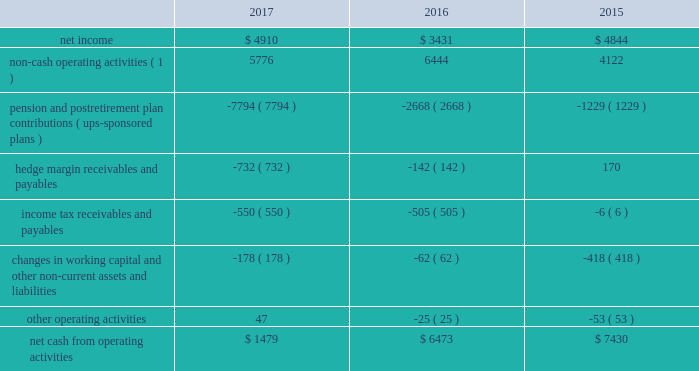United parcel service , inc .
And subsidiaries management's discussion and analysis of financial condition and results of operations liquidity and capital resources as of december 31 , 2017 , we had $ 4.069 billion in cash , cash equivalents and marketable securities .
We believe that our current cash position , access to the long-term debt capital markets and cash flow generated from operations should be adequate not only for operating requirements but also to enable us to complete our capital expenditure programs and to fund dividend payments , share repurchases and long-term debt payments through the next several years .
In addition , we have funds available from our commercial paper program and the ability to obtain alternative sources of financing .
We regularly evaluate opportunities to optimize our capital structure , including through issuances of debt to refinance existing debt and to fund ongoing cash needs .
Cash flows from operating activities the following is a summary of the significant sources ( uses ) of cash from operating activities ( amounts in millions ) : .
( 1 ) represents depreciation and amortization , gains and losses on derivative transactions and foreign exchange , deferred income taxes , provisions for uncollectible accounts , pension and postretirement benefit expense , stock compensation expense and other non-cash items .
Cash from operating activities remained strong throughout 2015 to 2017 .
Most of the variability in operating cash flows during the 2015 to 2017 time period relates to the funding of our company-sponsored pension and postretirement benefit plans ( and related cash tax deductions ) .
Except for discretionary or accelerated fundings of our plans , contributions to our company- sponsored pension plans have largely varied based on whether any minimum funding requirements are present for individual pension plans .
2022 we made discretionary contributions to our three primary company-sponsored u.s .
Pension plans totaling $ 7.291 , $ 2.461 and $ 1.030 billion in 2017 , 2016 and 2015 , respectively .
2022 the remaining contributions from 2015 to 2017 were largely due to contributions to our international pension plans and u.s .
Postretirement medical benefit plans .
Apart from the transactions described above , operating cash flow was impacted by changes in our working capital position , payments for income taxes and changes in hedge margin payables and receivables .
Cash payments for income taxes were $ 1.559 , $ 2.064 and $ 1.913 billion for 2017 , 2016 and 2015 , respectively , and were primarily impacted by the timing of current tax deductions .
The net hedge margin collateral ( paid ) /received from derivative counterparties was $ ( 732 ) , $ ( 142 ) and $ 170 million during 2017 , 2016 and 2015 , respectively , due to settlements and changes in the fair value of the derivative contracts used in our currency and interest rate hedging programs .
As of december 31 , 2017 , the total of our worldwide holdings of cash , cash equivalents and marketable securities were $ 4.069 billion , of which approximately $ 1.800 billion was held by foreign subsidiaries .
The amount of cash , cash equivalents and marketable securities held by our u.s .
And foreign subsidiaries fluctuates throughout the year due to a variety of factors , including the timing of cash receipts and disbursements in the normal course of business .
Cash provided by operating activities in the u.s .
Continues to be our primary source of funds to finance domestic operating needs , capital expenditures , share repurchases and dividend payments to shareowners .
As a result of the tax act , all cash , cash equivalents and marketable securities held by foreign subsidiaries are generally available for distribution to the u.s .
Without any u.s .
Federal income taxes .
Any such distributions may be subject to foreign withholding and u.s .
State taxes .
When amounts earned by foreign subsidiaries are expected to be indefinitely reinvested , no accrual for taxes is provided. .
What was the difference in millions of pension and postretirement plan contributions ( ups-sponsored plans ) from 2016 to 2017? 
Computations: (7794 - 2668)
Answer: 5126.0. 